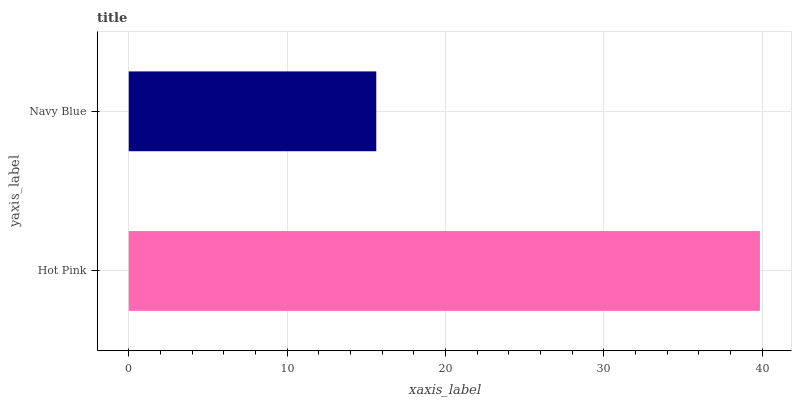Is Navy Blue the minimum?
Answer yes or no. Yes. Is Hot Pink the maximum?
Answer yes or no. Yes. Is Navy Blue the maximum?
Answer yes or no. No. Is Hot Pink greater than Navy Blue?
Answer yes or no. Yes. Is Navy Blue less than Hot Pink?
Answer yes or no. Yes. Is Navy Blue greater than Hot Pink?
Answer yes or no. No. Is Hot Pink less than Navy Blue?
Answer yes or no. No. Is Hot Pink the high median?
Answer yes or no. Yes. Is Navy Blue the low median?
Answer yes or no. Yes. Is Navy Blue the high median?
Answer yes or no. No. Is Hot Pink the low median?
Answer yes or no. No. 